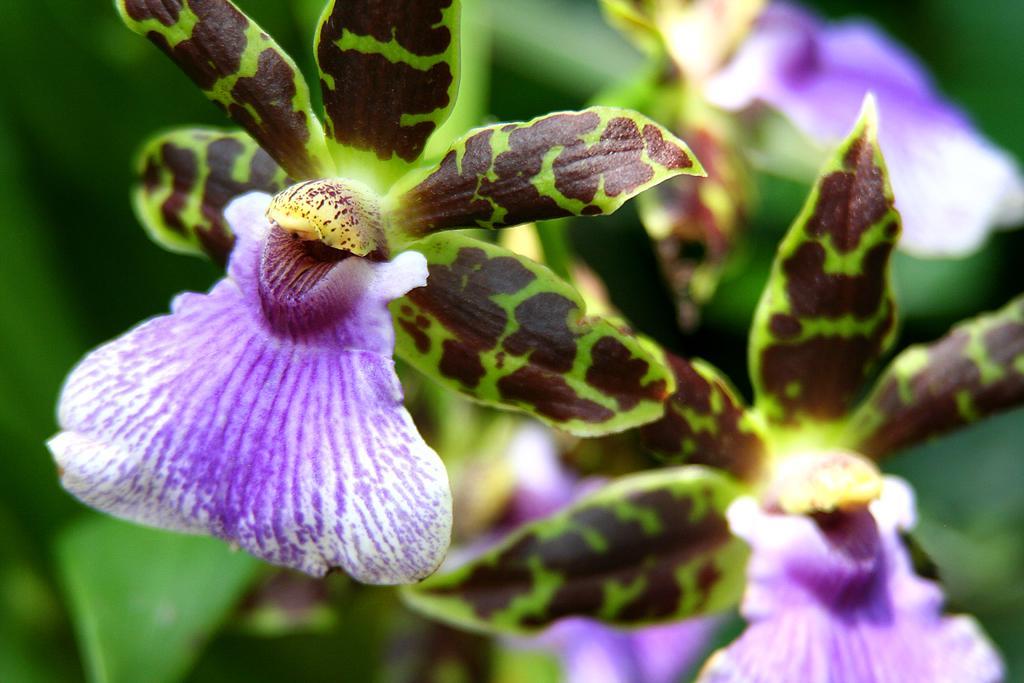How would you summarize this image in a sentence or two? In this image I can see a flower which is white and purple in color to a tree which is green and brown in color. I can see few flowers and few plants in the blurry background. 